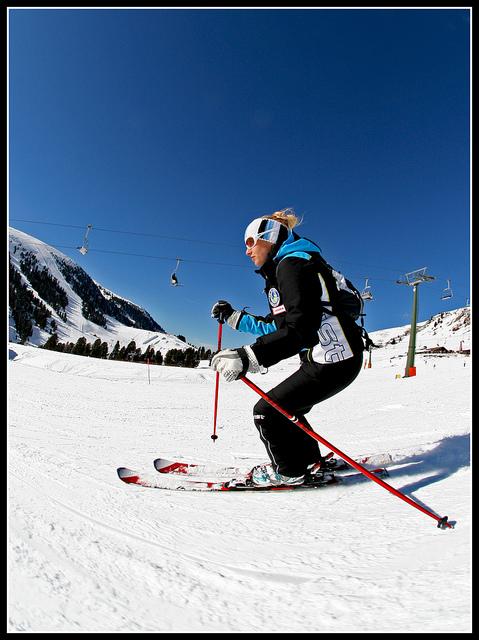What is she doing?
Give a very brief answer. Skiing. Is the day cold?
Quick response, please. Yes. Is the woman having fun?
Give a very brief answer. Yes. 